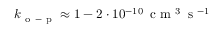<formula> <loc_0><loc_0><loc_500><loc_500>k _ { o - p } \approx 1 - 2 \cdot 1 0 ^ { - 1 0 } \, { c m ^ { 3 } \, s ^ { - 1 } }</formula> 